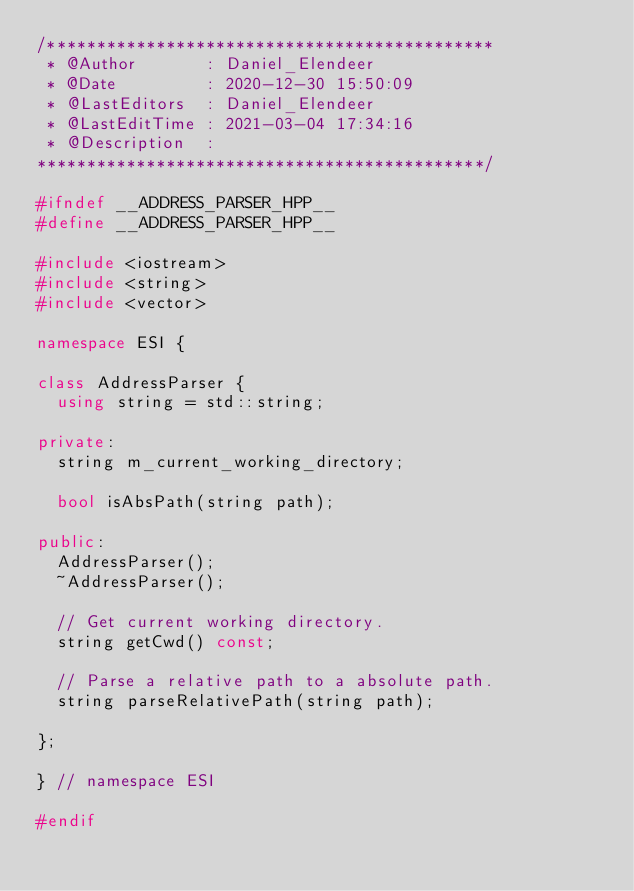Convert code to text. <code><loc_0><loc_0><loc_500><loc_500><_C++_>/*********************************************
 * @Author       : Daniel_Elendeer
 * @Date         : 2020-12-30 15:50:09
 * @LastEditors  : Daniel_Elendeer
 * @LastEditTime : 2021-03-04 17:34:16
 * @Description  :
*********************************************/

#ifndef __ADDRESS_PARSER_HPP__
#define __ADDRESS_PARSER_HPP__

#include <iostream>
#include <string>
#include <vector>

namespace ESI {

class AddressParser {
	using string = std::string;

private:
	string m_current_working_directory;

	bool isAbsPath(string path);

public:
	AddressParser();
	~AddressParser();

	// Get current working directory.
	string getCwd() const;

	// Parse a relative path to a absolute path.
	string parseRelativePath(string path);

};

} // namespace ESI

#endif
</code> 